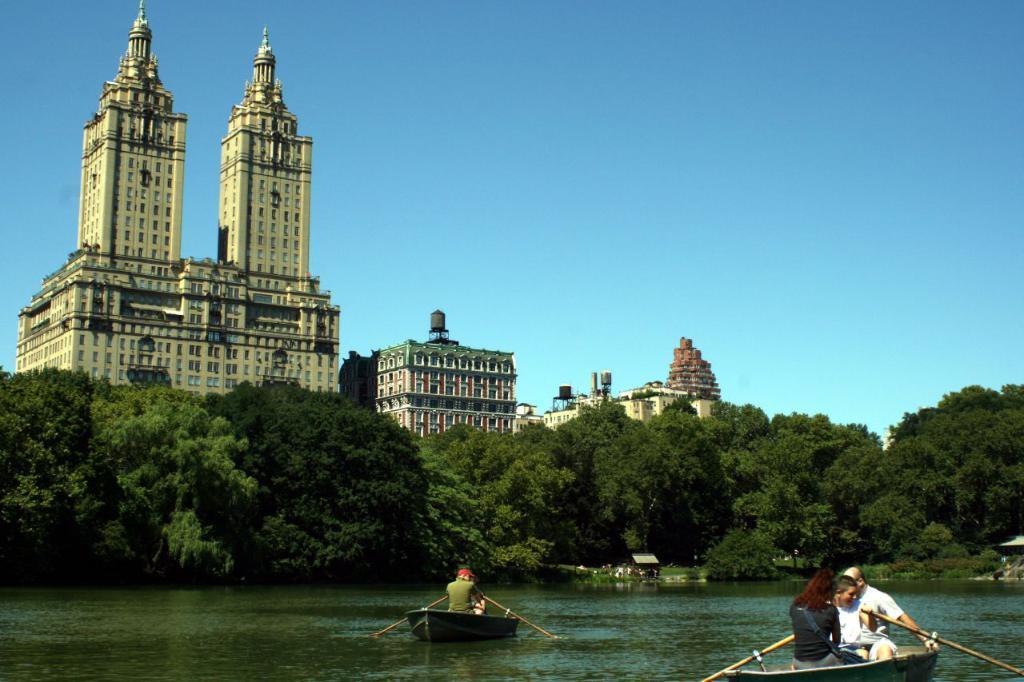Please provide a concise description of this image. In this image we can see the people rowing the boats on the water and also we can see some people sitting on the boats, there are some buildings and trees, in the background we can see the sky. 